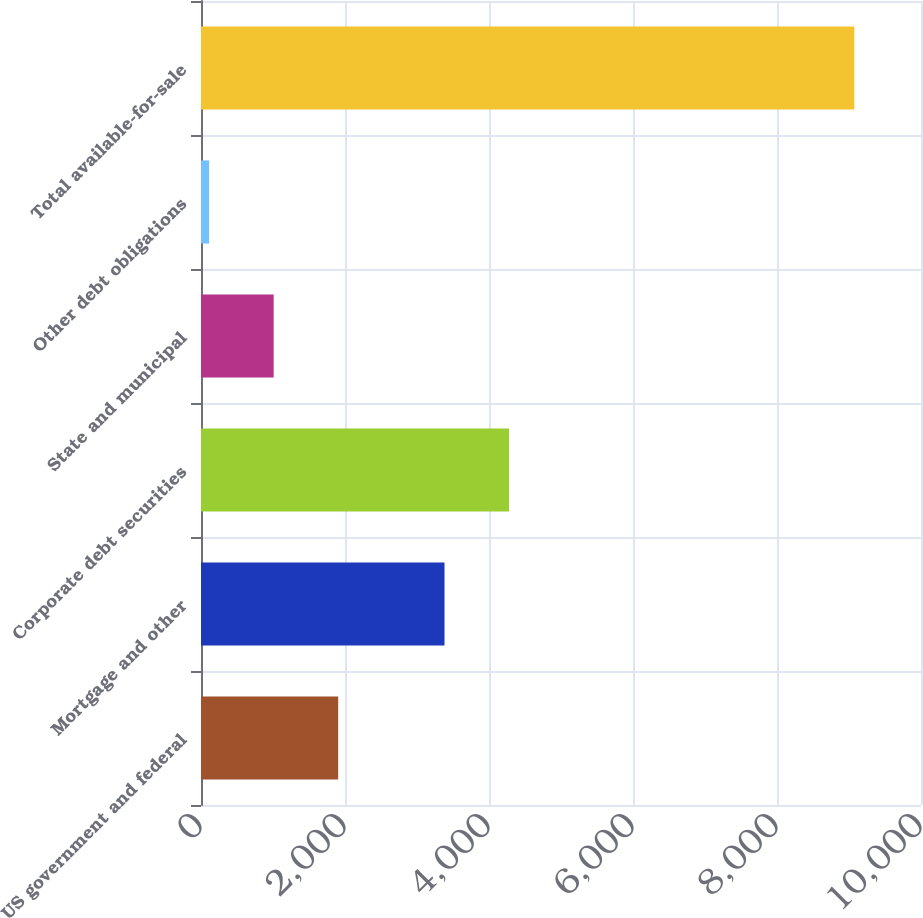Convert chart. <chart><loc_0><loc_0><loc_500><loc_500><bar_chart><fcel>US government and federal<fcel>Mortgage and other<fcel>Corporate debt securities<fcel>State and municipal<fcel>Other debt obligations<fcel>Total available-for-sale<nl><fcel>1905.2<fcel>3382<fcel>4278.1<fcel>1009.1<fcel>113<fcel>9074<nl></chart> 